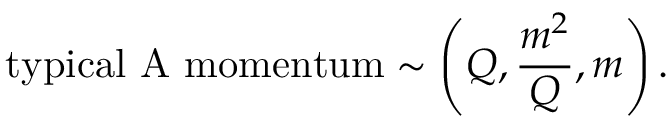Convert formula to latex. <formula><loc_0><loc_0><loc_500><loc_500>t y p i c a l A m o m e n t u m \sim \left ( Q , \frac { m ^ { 2 } } { Q } , m \right ) .</formula> 